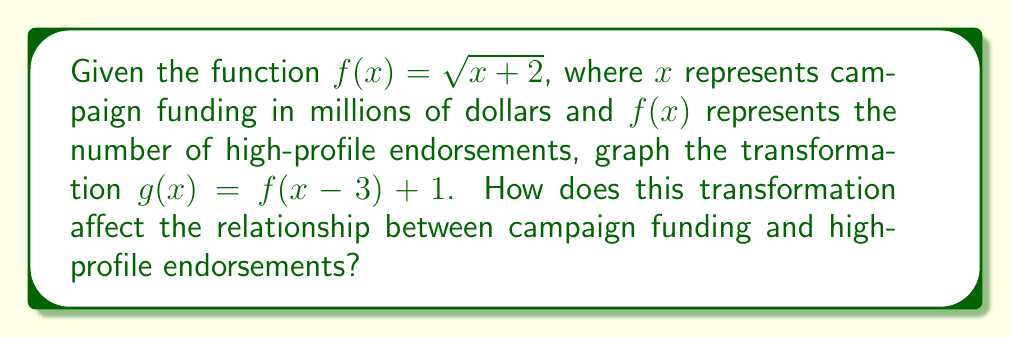Give your solution to this math problem. To graph the transformation $g(x) = f(x - 3) + 1$, we need to apply the following steps:

1. Start with the original function $f(x) = \sqrt{x + 2}$

2. Apply the horizontal shift:
   $f(x - 3)$ shifts the graph 3 units to the right
   This changes the function to $\sqrt{(x - 3) + 2} = \sqrt{x - 1}$

3. Apply the vertical shift:
   $f(x - 3) + 1$ shifts the graph 1 unit up
   The final transformed function is $g(x) = \sqrt{x - 1} + 1$

4. To graph $g(x)$:
   - The domain is $x \geq 1$ (since we need $x - 1 \geq 0$ for the square root)
   - The range is $y \geq 1$ (since $\sqrt{x - 1} \geq 0$ and we add 1)
   - The vertex of the parabola moves from (0, $\sqrt{2}$) to (3, 1)

[asy]
import graph;
size(200);
real f(real x) {return sqrt(x+2);}
real g(real x) {return sqrt(x-1)+1;}
draw(graph(f,0,4), blue);
draw(graph(g,1,7), red);
xaxis("x (Campaign funding in millions)", 0, 7, arrow=Arrow);
yaxis("y (Number of endorsements)", 0, 4, arrow=Arrow);
label("f(x)", (3,f(3)), N, blue);
label("g(x)", (6,g(6)), N, red);
[/asy]

The transformation affects the relationship between campaign funding and high-profile endorsements in the following ways:
1. Campaigns now need at least $1 million in funding to receive any endorsements (domain shift).
2. All campaigns receive at least 1 high-profile endorsement regardless of funding (vertical shift).
3. The rate of increase in endorsements relative to funding remains the same, but starts from a higher baseline.
Answer: The transformation shifts the graph 3 units right and 1 unit up, increasing the minimum funding needed for endorsements and guaranteeing at least one endorsement for all campaigns with sufficient funding. 